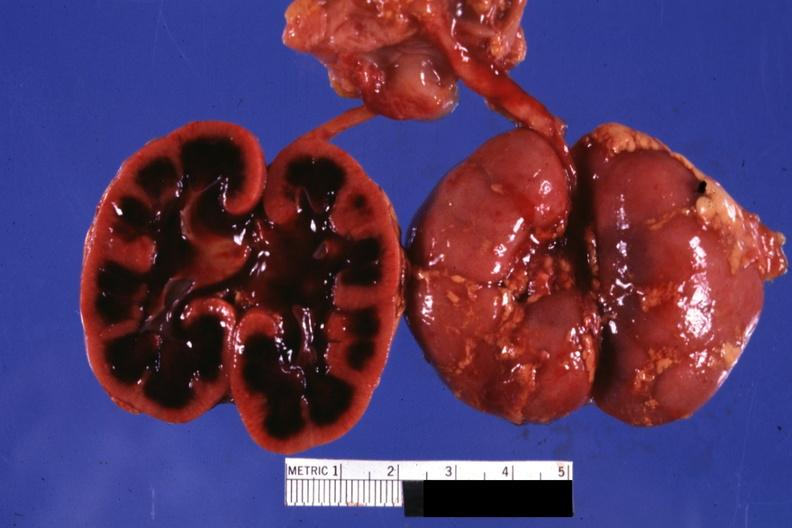what does this image show?
Answer the question using a single word or phrase. Typical cut surface appearance for severe ischemia 